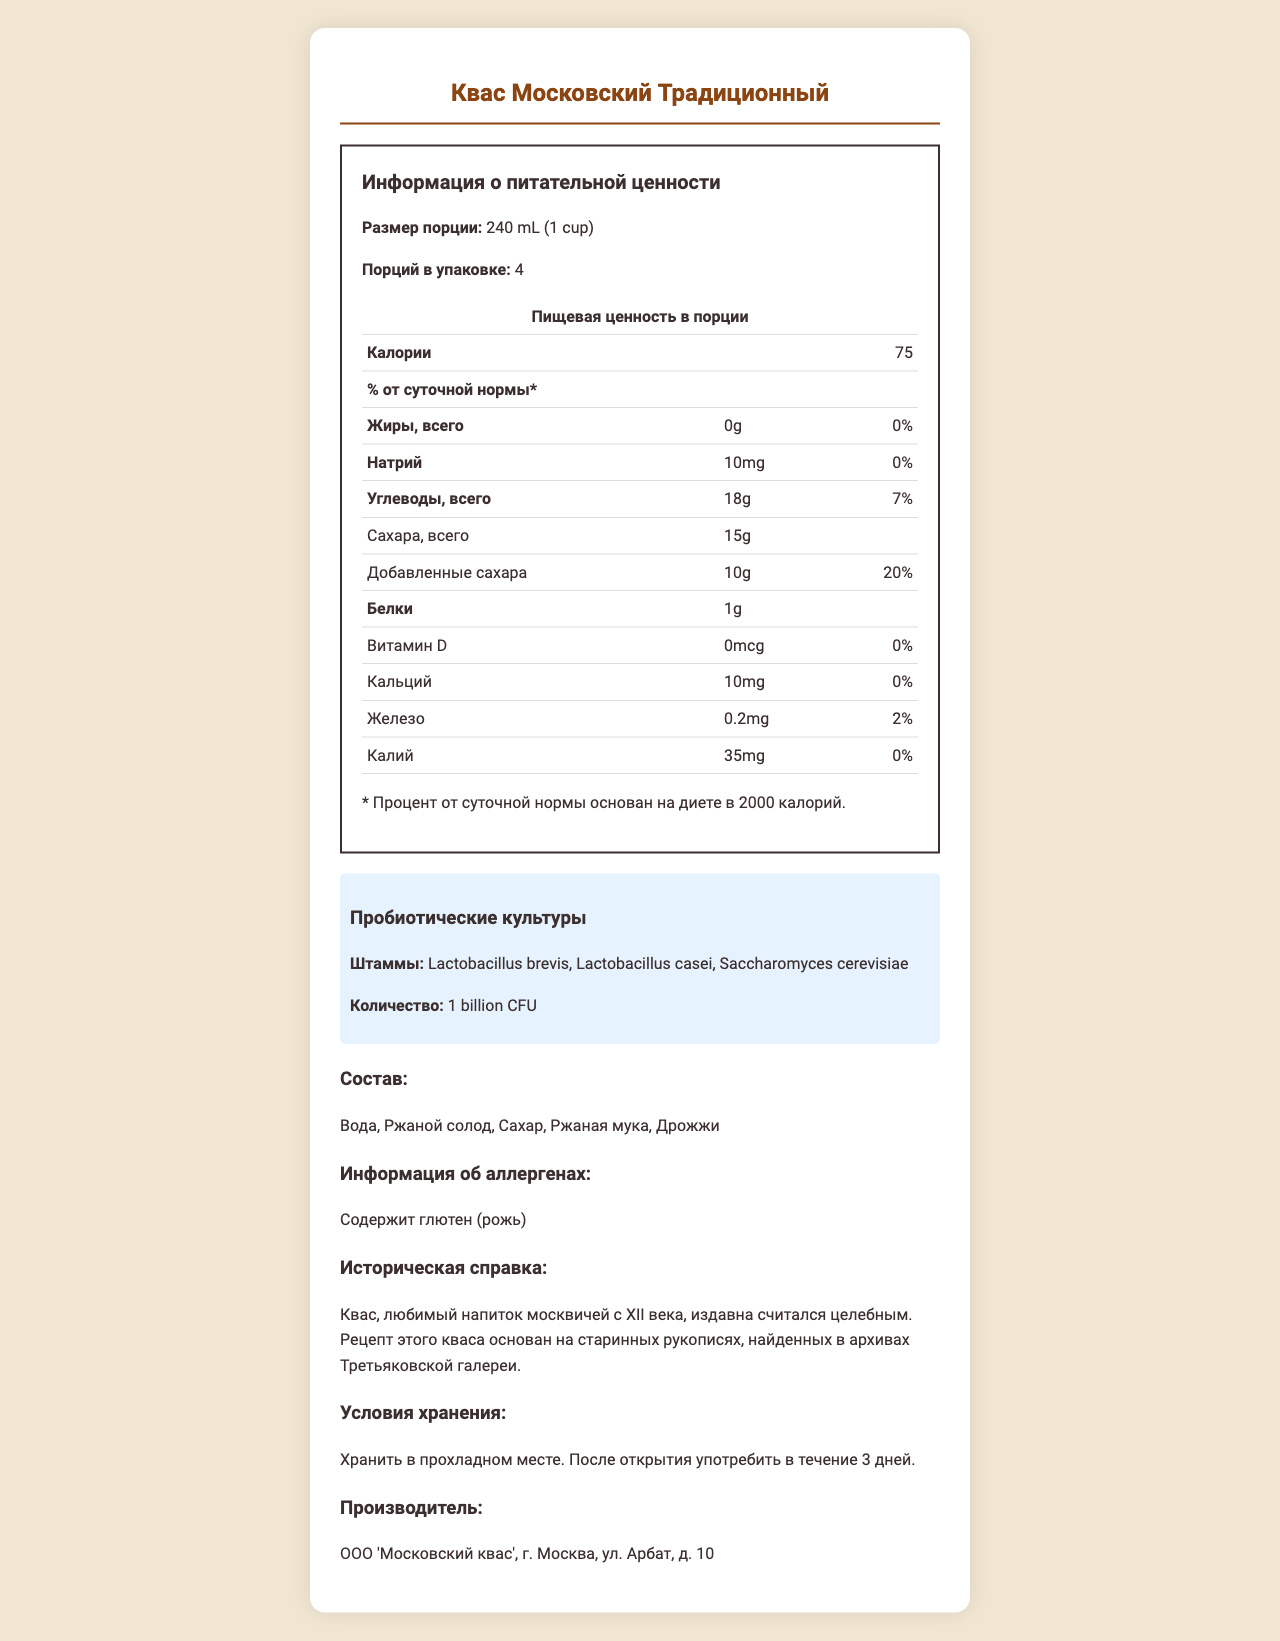What is the serving size of "Квас Московский Традиционный"? The serving size is mentioned under the "Размер порции".
Answer: 240 mL (1 cup) How many servings are in one container of this kvass? The number of servings per container is listed as "Порций в упаковке: 4".
Answer: 4 What is the calorie count per serving? The calorie count per serving is noted as "Калории: 75".
Answer: 75 Name one probiotic strain found in this kvass. "Лактобациллус бревис" is one of the probiotic strains listed under the "Штаммы" section.
Answer: Lactobacillus brevis What is the main carbohydrate content per serving? The total carbohydrate content per serving is given as "Углеводы, всего: 18g".
Answer: 18g Does this kvass contain any fat? It is clearly mentioned as "Жиры, всего: 0g", which indicates no fat content.
Answer: No Which of the following allergens does this kvass contain? A. Soy B. Dairy C. Gluten D. Nuts The allergen information specifies "Содержит глютен (рожь)", indicating it contains gluten.
Answer: C. Gluten How much added sugar is in one serving of kvass? A. 5g B. 10g C. 15g D. 20g The document lists added sugars as "Добавленные сахара: 10g".
Answer: B. 10g Does this kvass contain any vitamin D? The document shows "Витамин D: 0mcg", which means it does not contain any vitamin D.
Answer: No What is the historical significance of this kvass? The historical note mentions that "Рецепт этого кваса основан на старинных рукописях, найденных в архивах Третьяковской галереи."
Answer: The recipe is based on ancient manuscripts found in the archives of the Tretyakov Gallery. Summarize the nutritional content and special features of "Квас Московский Традиционный". This summary outlines the main nutritional information along with special features like the probiotic content and historical background provided in the document.
Answer: The kvass has 75 calories per 240 mL serving, contains 0g fat, 10mg sodium, 18g carbohydrates (with 15g total sugars and 10g added sugars), and 1g protein. It contains probiotic cultures (Lactobacillus brevis, Lactobacillus casei, Saccharomyces cerevisiae) at an amount of 1 billion CFU. The main ingredients include water, rye malt, sugar, rye flour, and yeast. It contains gluten (rye) and the recipe has historical significance, being based on ancient manuscripts. Where is this kvass manufactured? The manufacturer information is listed as "ООО 'Московский квас', г. Москва, ул. Арбат, д. 10".
Answer: ООО 'Московский квас', г. Москва, ул. Арбат, д. 10 How should this kvass be stored after opening? The storage information states "Хранить в прохладном месте. После открытия употребить в течение 3 дней."
Answer: In a cool place and consumed within 3 days. What is the recommended daily value of sodium for a diet of 2000 calories? The document does not provide the recommended daily value of sodium; it only lists the sodium content and its daily value percentage for this specific product.
Answer: Cannot be determined 